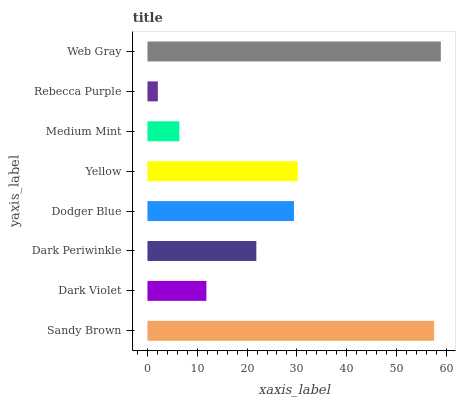Is Rebecca Purple the minimum?
Answer yes or no. Yes. Is Web Gray the maximum?
Answer yes or no. Yes. Is Dark Violet the minimum?
Answer yes or no. No. Is Dark Violet the maximum?
Answer yes or no. No. Is Sandy Brown greater than Dark Violet?
Answer yes or no. Yes. Is Dark Violet less than Sandy Brown?
Answer yes or no. Yes. Is Dark Violet greater than Sandy Brown?
Answer yes or no. No. Is Sandy Brown less than Dark Violet?
Answer yes or no. No. Is Dodger Blue the high median?
Answer yes or no. Yes. Is Dark Periwinkle the low median?
Answer yes or no. Yes. Is Medium Mint the high median?
Answer yes or no. No. Is Yellow the low median?
Answer yes or no. No. 